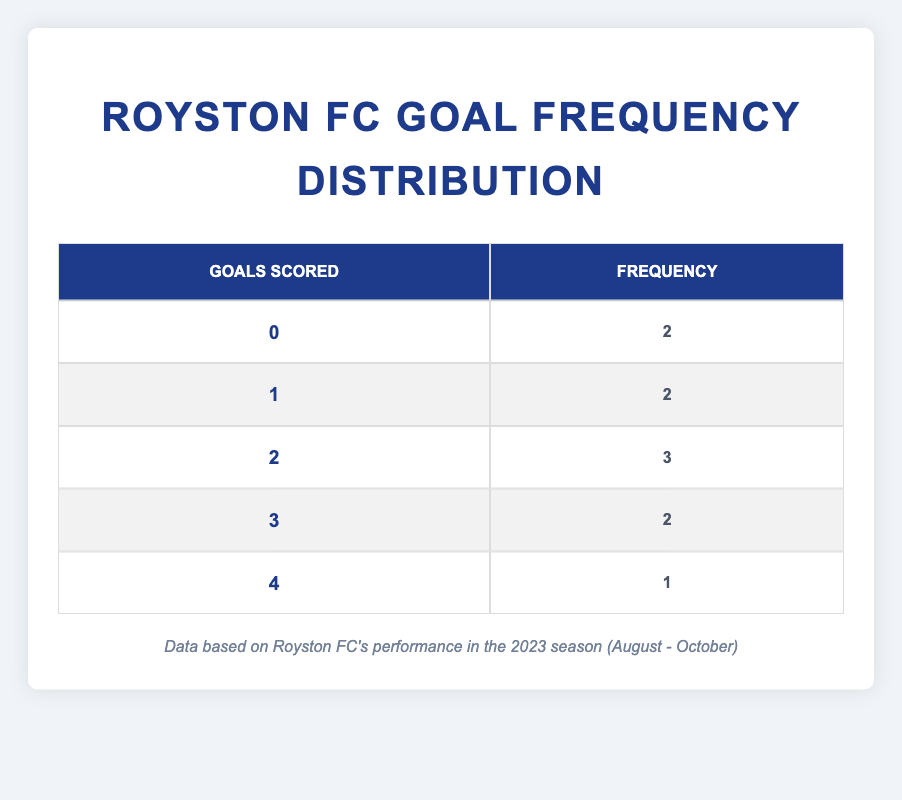What is the frequency of matches where Royston Football Club scored 0 goals? From the table, we can see that the score of 0 goals appears in two matches. Therefore, the frequency of matches with 0 goals is 2.
Answer: 2 How many matches did Royston Football Club score 3 goals? The table indicates that Royston scored 3 goals in two matches. Thus, the answer to this question is directly retrieved from the table.
Answer: 2 What is the total number of goals scored by the Royston Football Club? To find the total number of goals, we sum the goals scored: 2 + 3 + 1 + 0 + 4 + 2 + 1 + 2 + 0 + 3 = 18. Therefore, the total number of goals scored is 18.
Answer: 18 Is it true that Royston Football Club has more matches with 2 goals scored than matches with 1 goal scored? According to the table, Royston scored 2 goals in three matches and 1 goal in two matches. Since three is greater than two, it is true.
Answer: Yes What is the average number of goals scored per match by Royston Football Club this season? To find the average, we take the total number of goals scored (18) and divide it by the total number of matches played, which is 10. Therefore, the average is 18 / 10 = 1.8.
Answer: 1.8 How many more times did Royston score 2 goals compared to 4 goals? The table shows that Royston scored 2 goals in three matches and 4 goals in one match. To find the difference, we subtract 1 from 3, which gives us 2.
Answer: 2 What percentage of the matches ended with at least 2 goals scored? There are five matches where Royston scored 2 or more goals (2, 3, 4). To find the percentage, we divide the number of these matches (5) by the total number of matches (10) and multiply by 100. Thus, (5/10) * 100 = 50%.
Answer: 50% How many more matches had scores of 0 than scores of 4? The table states that there are two matches with a score of 0 and one match with a score of 4. By subtracting 1 from 2, we find there is one more match with 0 goals than 4 goals.
Answer: 1 